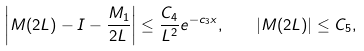Convert formula to latex. <formula><loc_0><loc_0><loc_500><loc_500>\left | M ( 2 L ) - I - \frac { M _ { 1 } } { 2 L } \right | \leq \frac { C _ { 4 } } { L ^ { 2 } } e ^ { - c _ { 3 } x } , \quad | M ( 2 L ) | \leq C _ { 5 } ,</formula> 